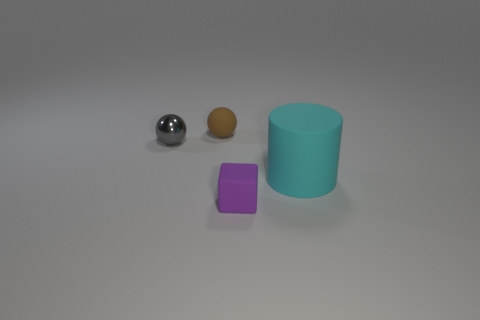Add 2 cyan rubber cylinders. How many objects exist? 6 Subtract all blocks. How many objects are left? 3 Add 1 tiny red cubes. How many tiny red cubes exist? 1 Subtract 0 blue blocks. How many objects are left? 4 Subtract all tiny shiny blocks. Subtract all small brown matte objects. How many objects are left? 3 Add 2 matte objects. How many matte objects are left? 5 